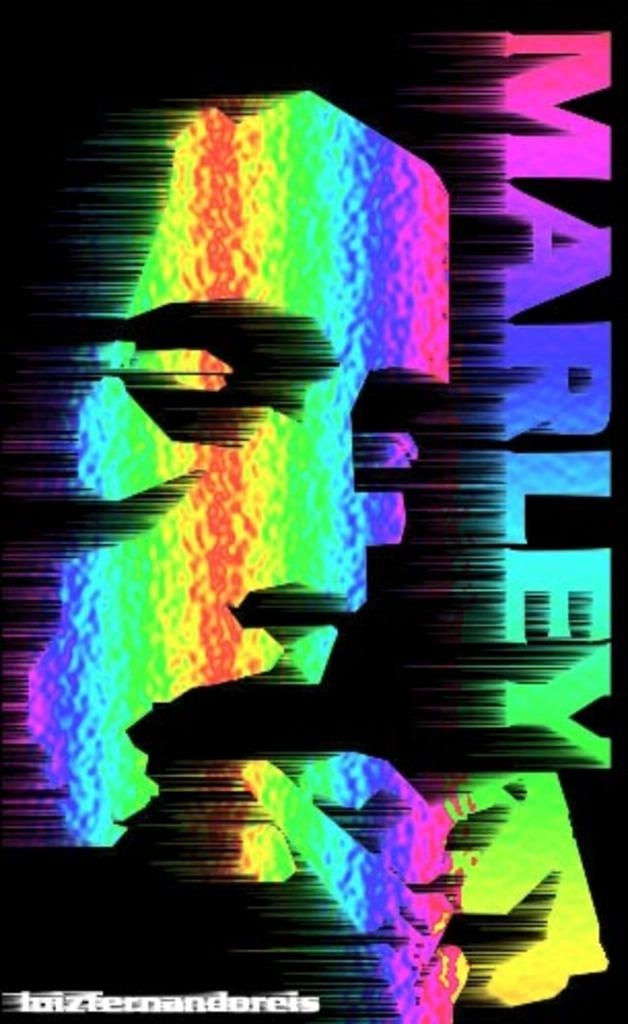<image>
Give a short and clear explanation of the subsequent image. Colorful poster with the word Marley on the right. 